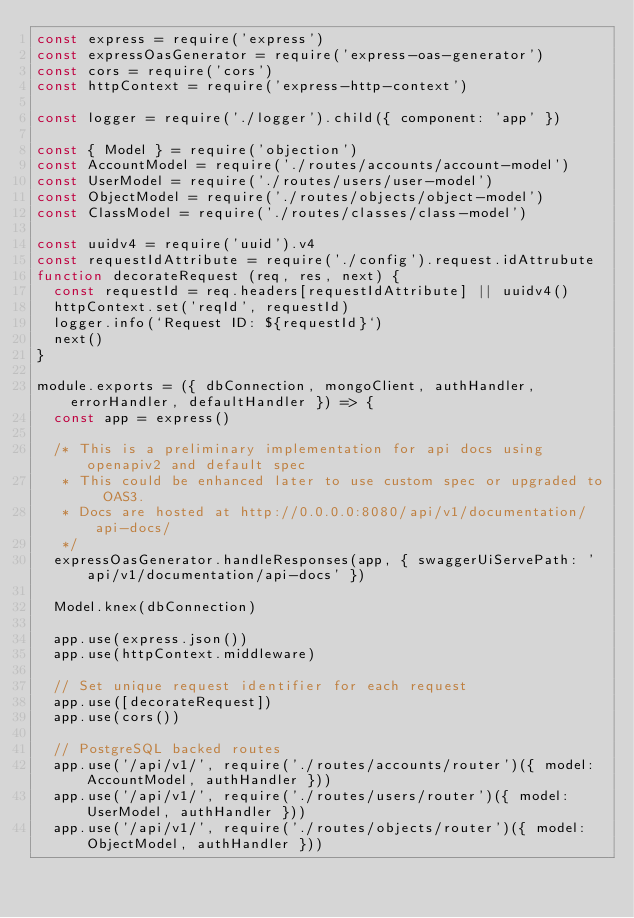<code> <loc_0><loc_0><loc_500><loc_500><_JavaScript_>const express = require('express')
const expressOasGenerator = require('express-oas-generator')
const cors = require('cors')
const httpContext = require('express-http-context')

const logger = require('./logger').child({ component: 'app' })

const { Model } = require('objection')
const AccountModel = require('./routes/accounts/account-model')
const UserModel = require('./routes/users/user-model')
const ObjectModel = require('./routes/objects/object-model')
const ClassModel = require('./routes/classes/class-model')

const uuidv4 = require('uuid').v4
const requestIdAttribute = require('./config').request.idAttrubute
function decorateRequest (req, res, next) {
  const requestId = req.headers[requestIdAttribute] || uuidv4()
  httpContext.set('reqId', requestId)
  logger.info(`Request ID: ${requestId}`)
  next()
}

module.exports = ({ dbConnection, mongoClient, authHandler, errorHandler, defaultHandler }) => {
  const app = express()

  /* This is a preliminary implementation for api docs using openapiv2 and default spec
   * This could be enhanced later to use custom spec or upgraded to OAS3.
   * Docs are hosted at http://0.0.0.0:8080/api/v1/documentation/api-docs/
   */
  expressOasGenerator.handleResponses(app, { swaggerUiServePath: 'api/v1/documentation/api-docs' })

  Model.knex(dbConnection)

  app.use(express.json())
  app.use(httpContext.middleware)

  // Set unique request identifier for each request
  app.use([decorateRequest])
  app.use(cors())

  // PostgreSQL backed routes
  app.use('/api/v1/', require('./routes/accounts/router')({ model: AccountModel, authHandler }))
  app.use('/api/v1/', require('./routes/users/router')({ model: UserModel, authHandler }))
  app.use('/api/v1/', require('./routes/objects/router')({ model: ObjectModel, authHandler }))</code> 